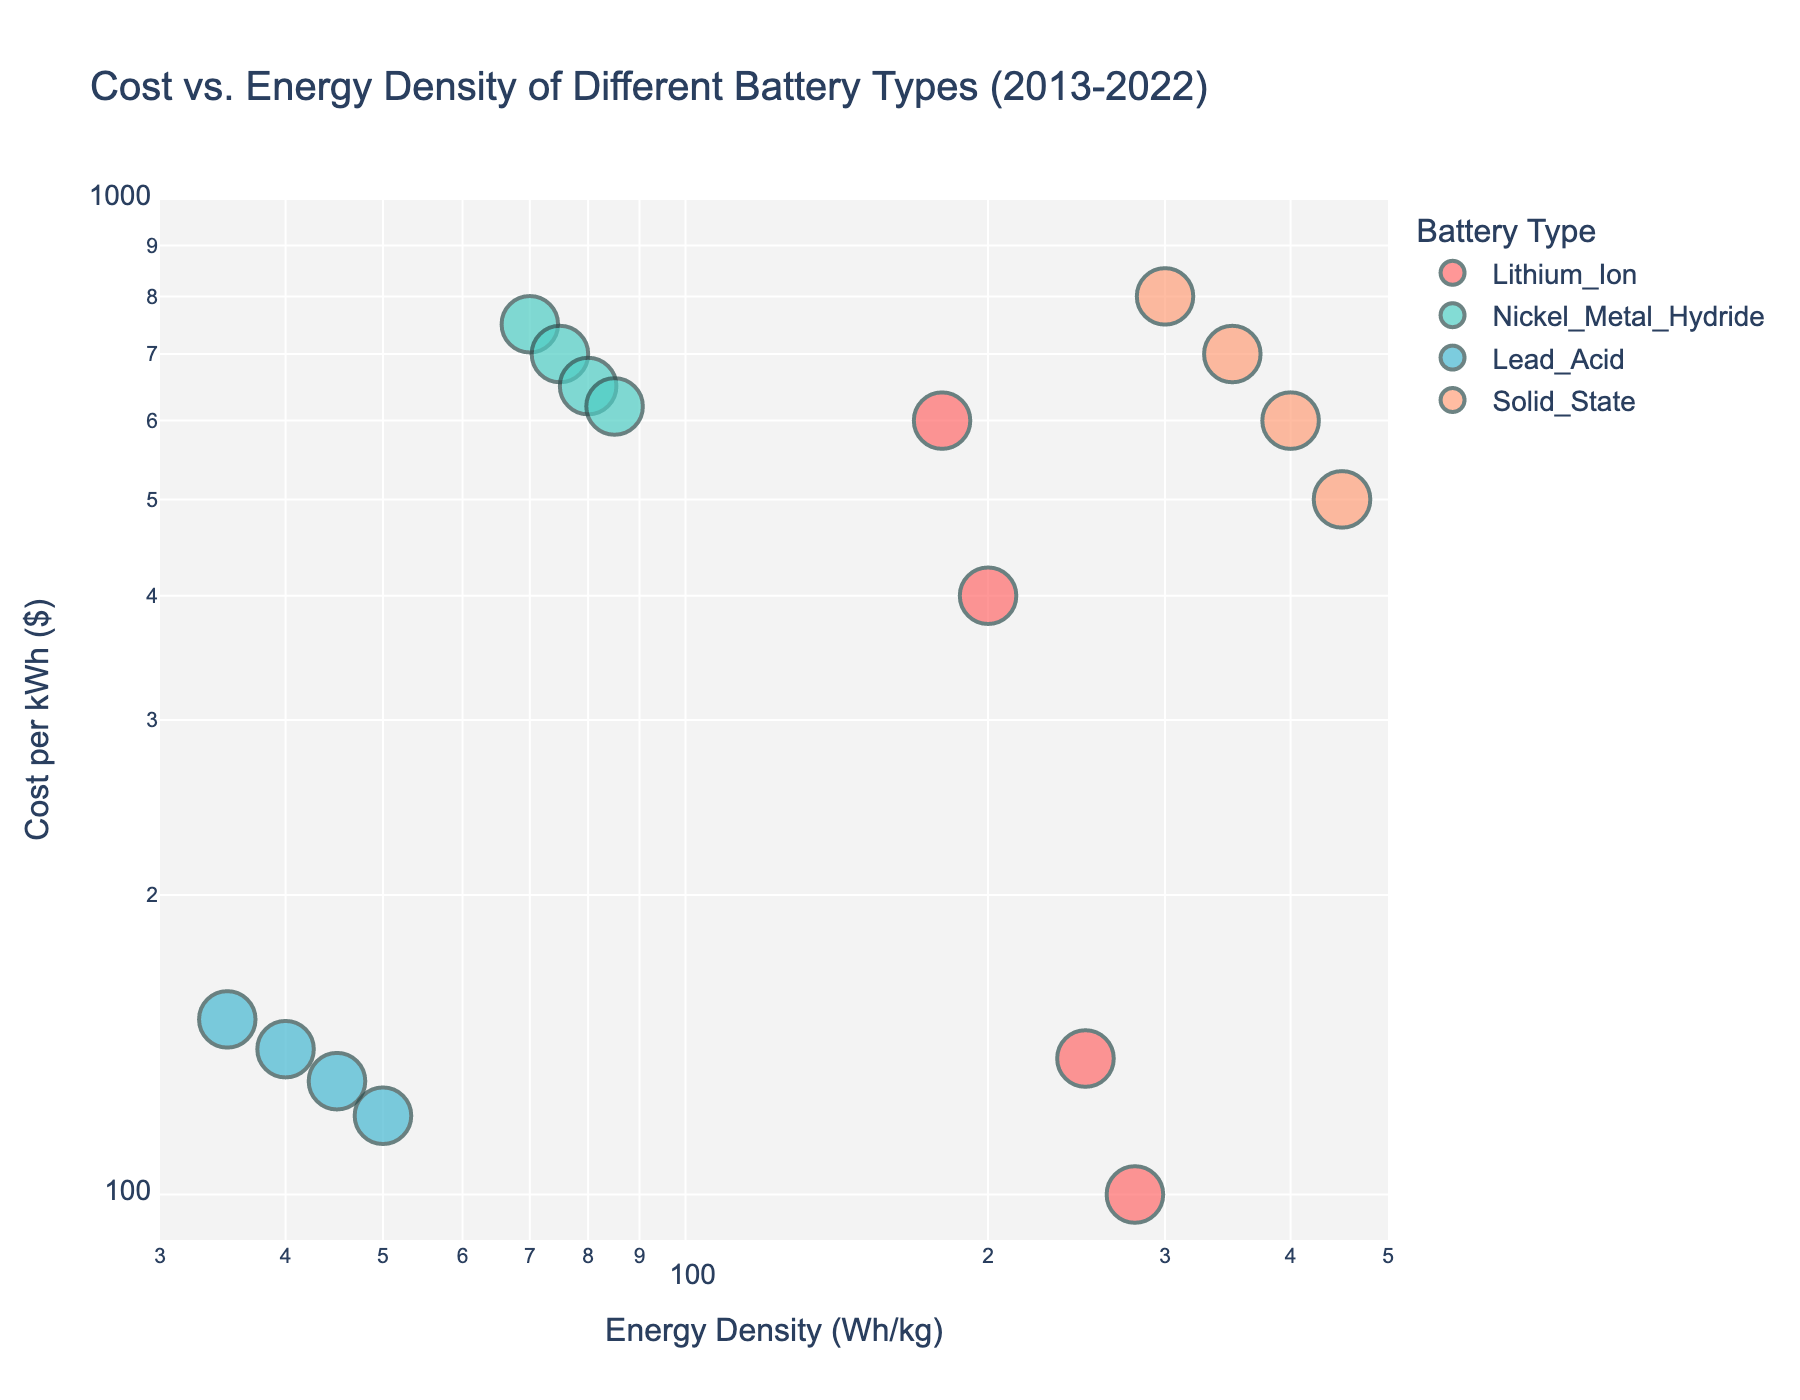what is the title of the plot? The title is placed at the top of the figure and indicates what the plot is about. By looking directly at the plot, we can read the title.
Answer: Cost vs. Energy Density of Different Battery Types (2013-2022) Which battery type had the highest energy density in 2022? To determine this, we look at the points representing 2022 and compare the energy densities on the x-axis. The Solid_State battery type has the highest value.
Answer: Solid_State What trend can be observed for Lithium_Ion batteries from 2013 to 2022? By following the progression of the points for Lithium_Ion from left to right, it’s apparent that energy density increases, and cost decreases over time, indicated by the arrows in the figure.
Answer: Increasing energy density and decreasing cost How many data points are there for Lead_Acid batteries? Counting the points associated with Lead_Acid based on the color defined in the legend, we see four data points ranging from 2013 to 2022.
Answer: Four Which year has the largest size marker, and what battery type does it represent? Marker size represents the year. The largest marker size is for 2022, and by identifying which battery type this marker belongs to in the legend, we can tell that it represents the Solid_State battery type.
Answer: 2022, Solid_State How does the cost per kWh of Nickel_Metal_Hydride batteries change from 2013 to 2022? By examining the Y-axis values for Nickel_Metal_Hydride in these years, we see a steady decrease in cost at each subsequent year as shown by the points moving lower on the y-axis.
Answer: Decreases Compare the energy density of lead_acid batteries in 2013 and 2022. What is the difference? Look at the x-axis values associated with Lead_Acid data points in 2013 and 2022. 2022 has a density of 50 Wh/kg and 2013 has 35 Wh/kg. The difference is 50 - 35.
Answer: 15 Wh/kg For which battery type is the change in energy density from 2013 to 2022 the greatest? We compare the difference in the x-axis values for each battery type between 2013 and 2022. Solid_State shows the largest increase from 300 Wh/kg to 450 Wh/kg, which is a 150 Wh/kg change.
Answer: Solid_State Which battery type saw the least improvement in cost per kWh between 2013 and 2022? Examine the y-axis values for each battery type from 2013 to 2022. Nickel_Metal_Hydride had the smallest change, going from 750 to 620 for a difference of 130.
Answer: Nickel_Metal_Hydride 